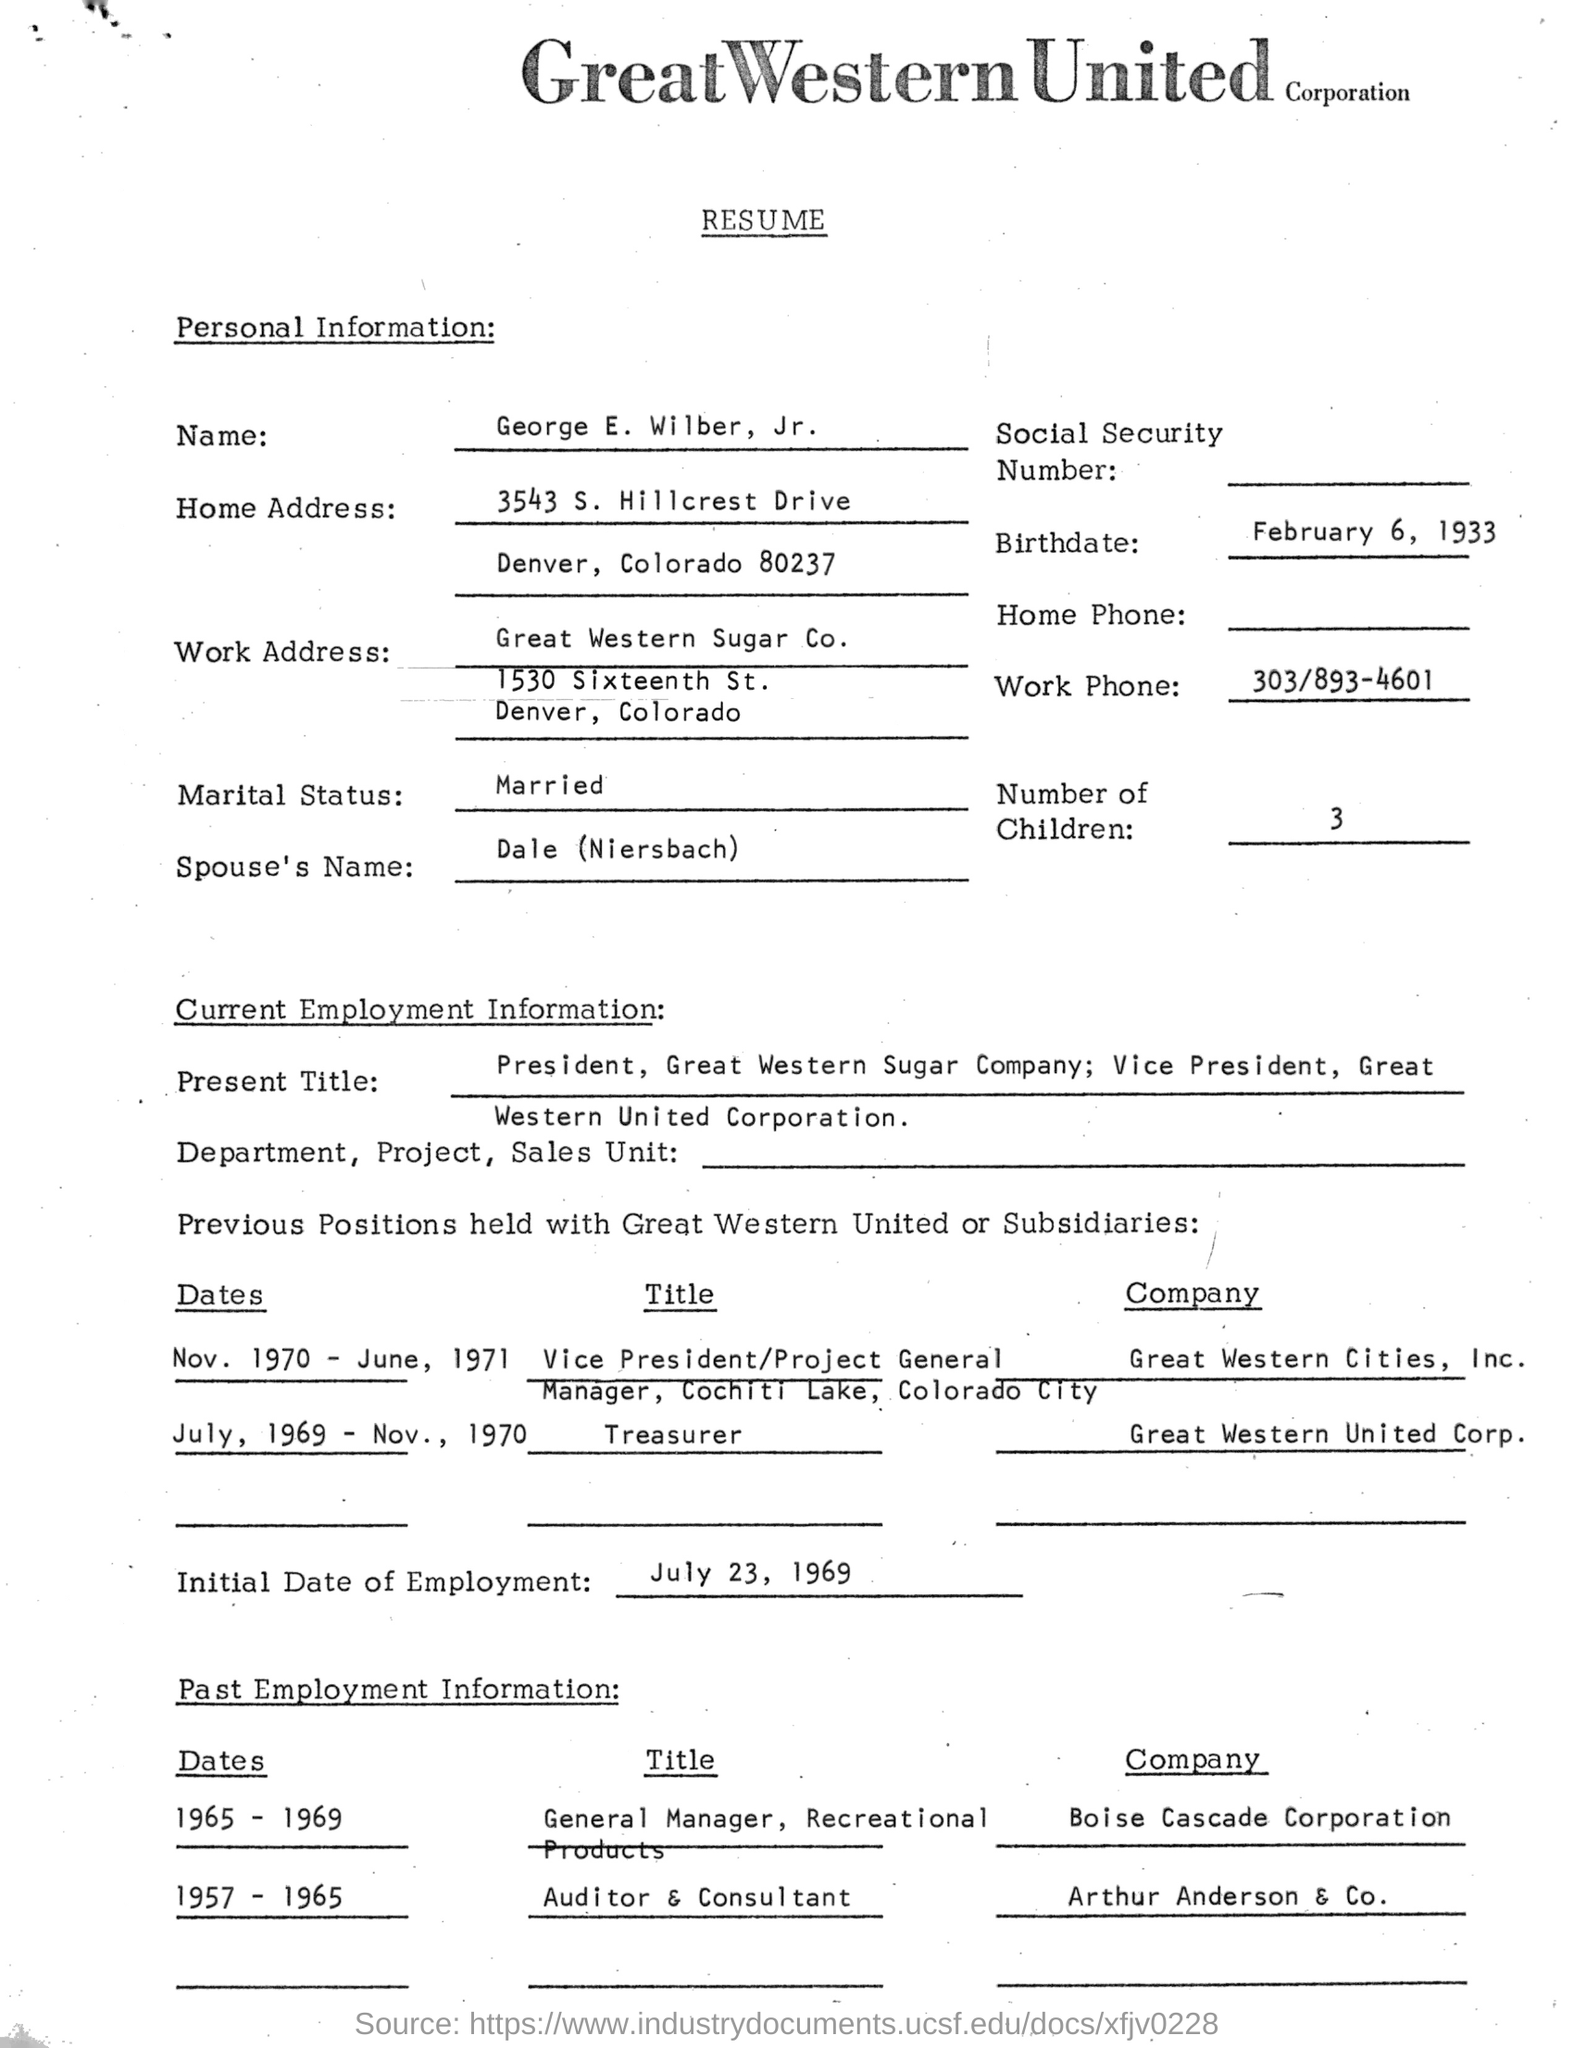List a handful of essential elements in this visual. George E. Wilber Jr. was born on February 6, 1933. The resume provided is for George E. Wilber, Jr. The individual's work phone number listed is 303/893-4601. The initial date of employment is July 23, 1969. The spouse's name of George E. Wilber, Jr. is Dale (Niersbach). 